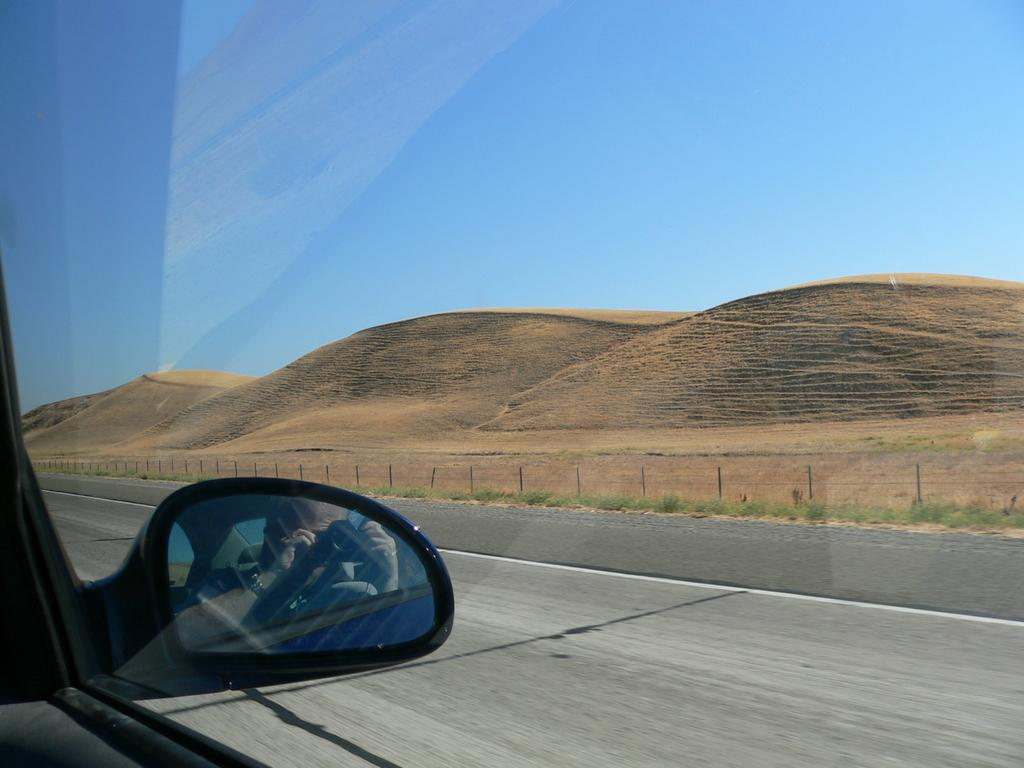What object is the main focus of the image? The main focus of the image is a vehicle side mirror. What can be seen in the side mirror's reflection? The side mirror reflects a person. What type of environment is visible in the image? There is a road, a fence, grass, hills, and the sky visible in the image. What type of liquid can be seen flowing through the dinosaurs in the image? There are no dinosaurs present in the image, so there is no liquid flowing through them. 